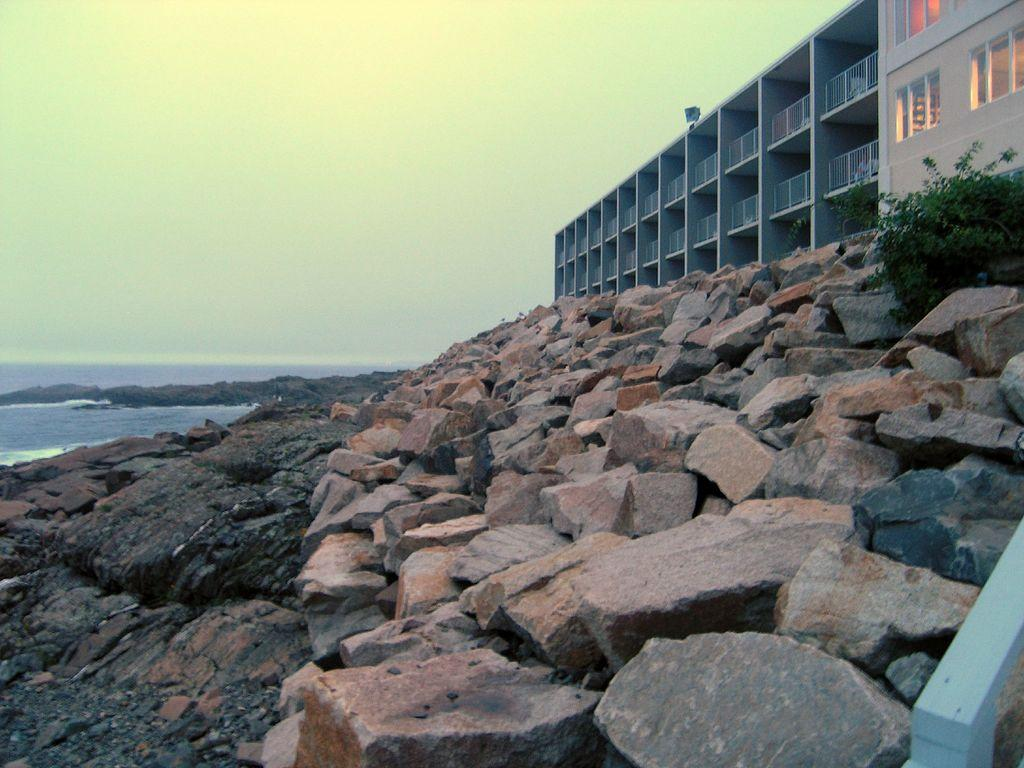What type of natural elements can be seen in the image? There are stones and plants visible in the image. What else can be seen in the image besides natural elements? There is water visible in the image, as well as buildings. What is visible in the background of the image? The sky is visible in the background of the image. What type of idea is being expressed by the cabbage in the image? There is no cabbage present in the image, so it is not possible to determine what idea might be expressed by a cabbage. 